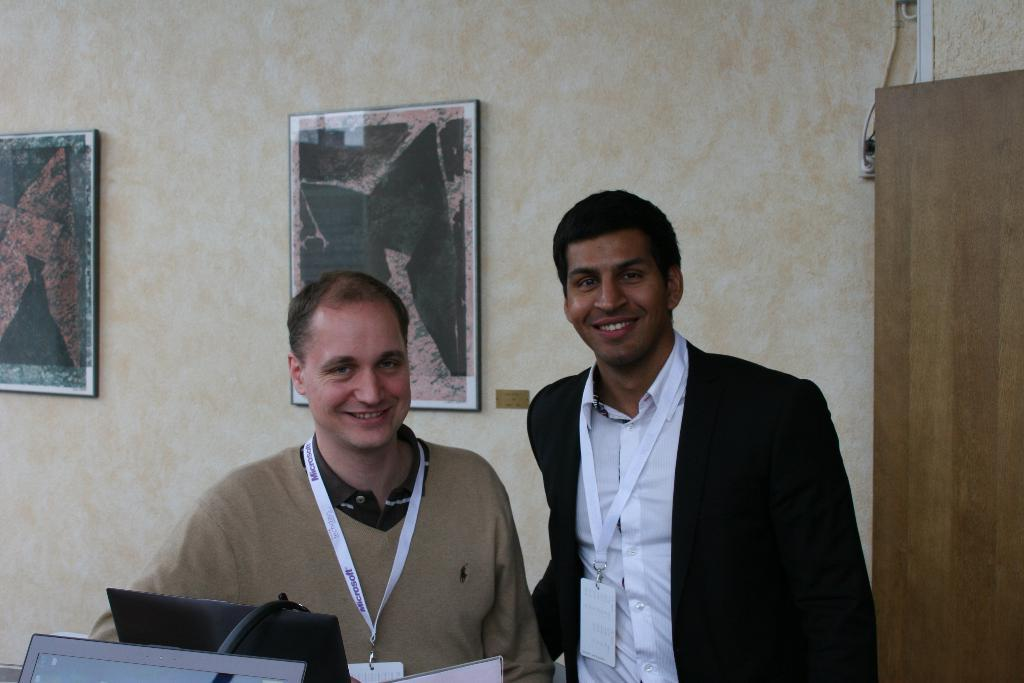How many people are in the image? There are two people in the image. Can you describe the position of one of the people? One person is standing on the right side. What is the person on the right side wearing? The person on the right side is wearing a black suit. What type of hospital equipment can be seen near the person on the left side? There is no person on the left side in the image, and no hospital equipment is visible. 